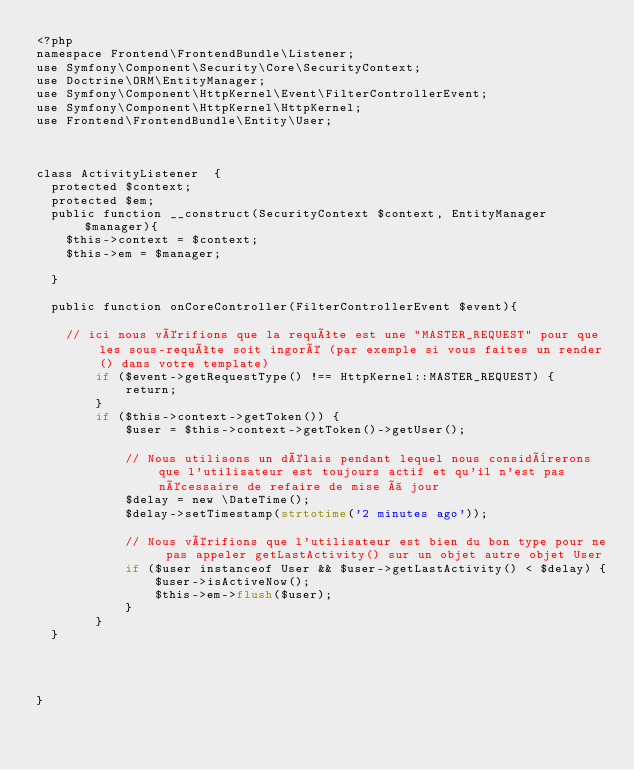Convert code to text. <code><loc_0><loc_0><loc_500><loc_500><_PHP_><?php
namespace Frontend\FrontendBundle\Listener;
use Symfony\Component\Security\Core\SecurityContext;
use Doctrine\ORM\EntityManager;
use Symfony\Component\HttpKernel\Event\FilterControllerEvent;
use Symfony\Component\HttpKernel\HttpKernel;
use Frontend\FrontendBundle\Entity\User;



class ActivityListener  {
  protected $context;
  protected $em;
  public function __construct(SecurityContext $context, EntityManager $manager){
    $this->context = $context;
    $this->em = $manager;

  }

  public function onCoreController(FilterControllerEvent $event){

    // ici nous vérifions que la requête est une "MASTER_REQUEST" pour que les sous-requête soit ingoré (par exemple si vous faites un render() dans votre template)
        if ($event->getRequestType() !== HttpKernel::MASTER_REQUEST) {
            return;
        }
        if ($this->context->getToken()) {
            $user = $this->context->getToken()->getUser();

            // Nous utilisons un délais pendant lequel nous considèrerons que l'utilisateur est toujours actif et qu'il n'est pas nécessaire de refaire de mise à jour
            $delay = new \DateTime();
            $delay->setTimestamp(strtotime('2 minutes ago'));

            // Nous vérifions que l'utilisateur est bien du bon type pour ne pas appeler getLastActivity() sur un objet autre objet User
            if ($user instanceof User && $user->getLastActivity() < $delay) {
                $user->isActiveNow();
                $this->em->flush($user);
            }
        }
  }




}
</code> 